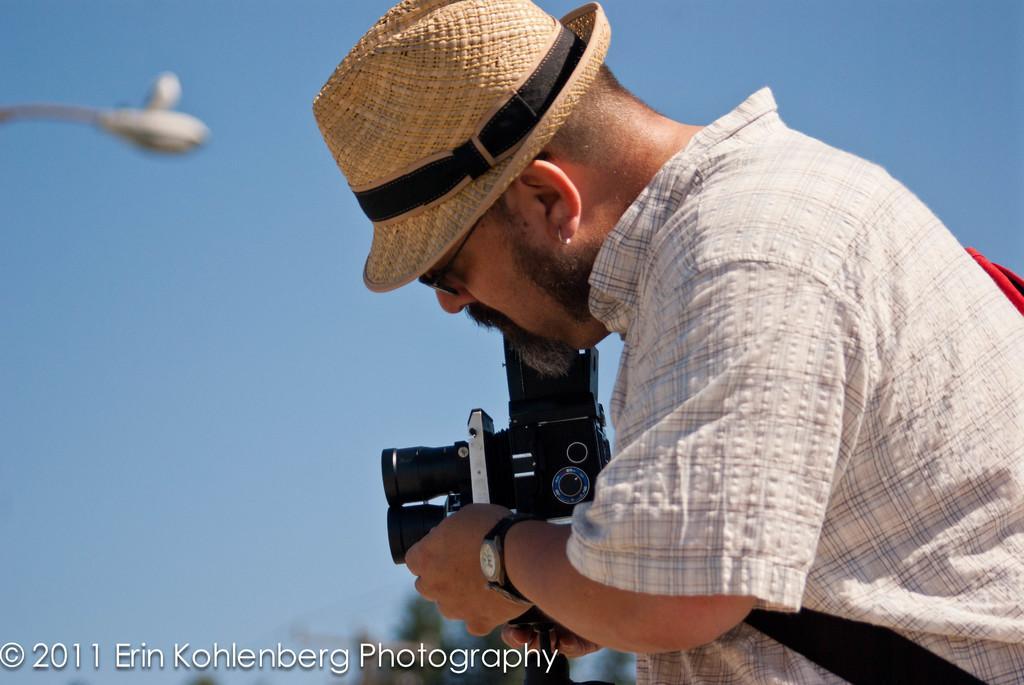Can you describe this image briefly? In the foreground of this image, on the right, there is a man wearing a hat and holding a camera. In the background, there is the sky and a street light. 